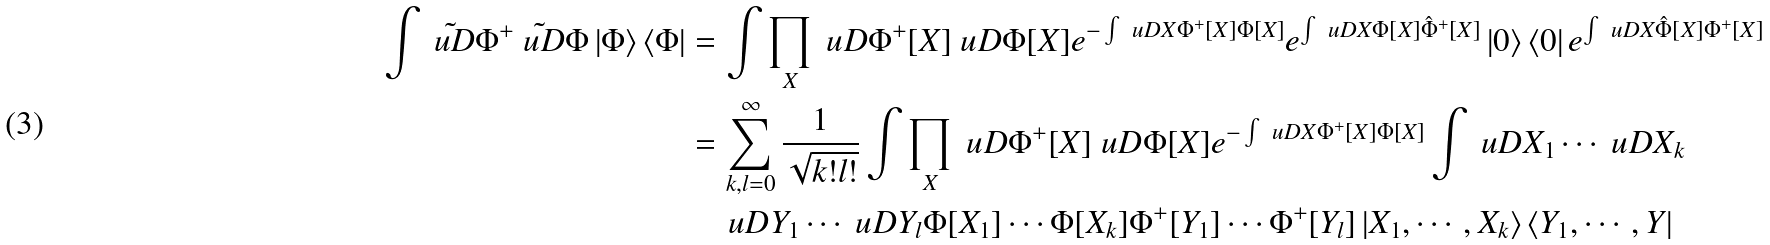Convert formula to latex. <formula><loc_0><loc_0><loc_500><loc_500>\int \tilde { \ u D } \Phi ^ { + } \tilde { \ u D } \Phi \left | \Phi \right > \left < \Phi \right | & = \int \prod _ { X } \ u D \Phi ^ { + } [ X ] \ u D \Phi [ X ] e ^ { - \int \ u D X \Phi ^ { + } [ X ] \Phi [ X ] } e ^ { \int \ u D X \Phi [ X ] \hat { \Phi } ^ { + } [ X ] } \left | 0 \right > \left < 0 \right | e ^ { \int \ u D X \hat { \Phi } [ X ] \Phi ^ { + } [ X ] } \\ & = \sum _ { k , l = 0 } ^ { \infty } \frac { 1 } { \sqrt { k ! l ! } } \int \prod _ { X } \ u D \Phi ^ { + } [ X ] \ u D \Phi [ X ] e ^ { - \int \ u D X \Phi ^ { + } [ X ] \Phi [ X ] } \int \ u D X _ { 1 } \cdots \ u D X _ { k } \\ & \quad \ u D Y _ { 1 } \cdots \ u D Y _ { l } \Phi [ X _ { 1 } ] \cdots \Phi [ X _ { k } ] \Phi ^ { + } [ Y _ { 1 } ] \cdots \Phi ^ { + } [ Y _ { l } ] \left | X _ { 1 } , \cdots , X _ { k } \right > \left < Y _ { 1 } , \cdots , Y \right |</formula> 